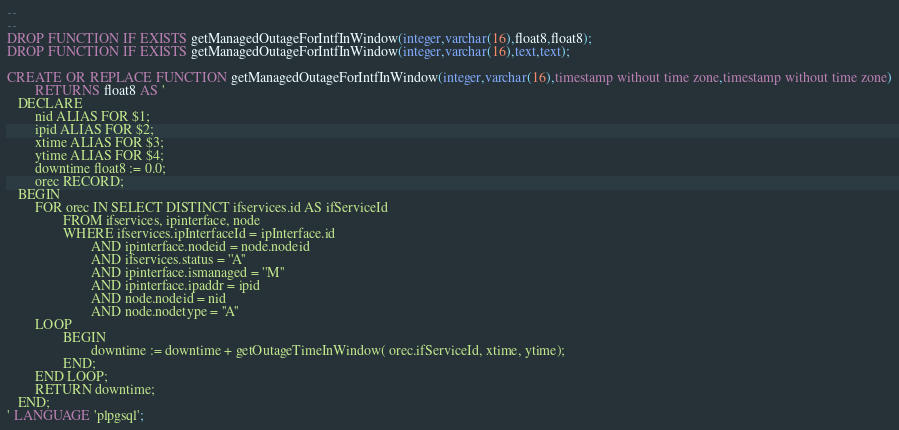Convert code to text. <code><loc_0><loc_0><loc_500><loc_500><_SQL_>--
--
DROP FUNCTION IF EXISTS getManagedOutageForIntfInWindow(integer,varchar(16),float8,float8);
DROP FUNCTION IF EXISTS getManagedOutageForIntfInWindow(integer,varchar(16),text,text);

CREATE OR REPLACE FUNCTION getManagedOutageForIntfInWindow(integer,varchar(16),timestamp without time zone,timestamp without time zone)
        RETURNS float8 AS '
   DECLARE
        nid ALIAS FOR $1;
        ipid ALIAS FOR $2;
        xtime ALIAS FOR $3;
        ytime ALIAS FOR $4;
        downtime float8 := 0.0;
        orec RECORD;
   BEGIN
        FOR orec IN SELECT DISTINCT ifservices.id AS ifServiceId 
                FROM ifservices, ipinterface, node 
                WHERE ifservices.ipInterfaceId = ipInterface.id 
                        AND ipinterface.nodeid = node.nodeid 
                        AND ifservices.status = ''A'' 
                        AND ipinterface.ismanaged = ''M'' 
                        AND ipinterface.ipaddr = ipid 
                        AND node.nodeid = nid 
                        AND node.nodetype = ''A''
        LOOP
                BEGIN
                        downtime := downtime + getOutageTimeInWindow( orec.ifServiceId, xtime, ytime);
                END;
        END LOOP;
        RETURN downtime;
   END;
' LANGUAGE 'plpgsql';
</code> 